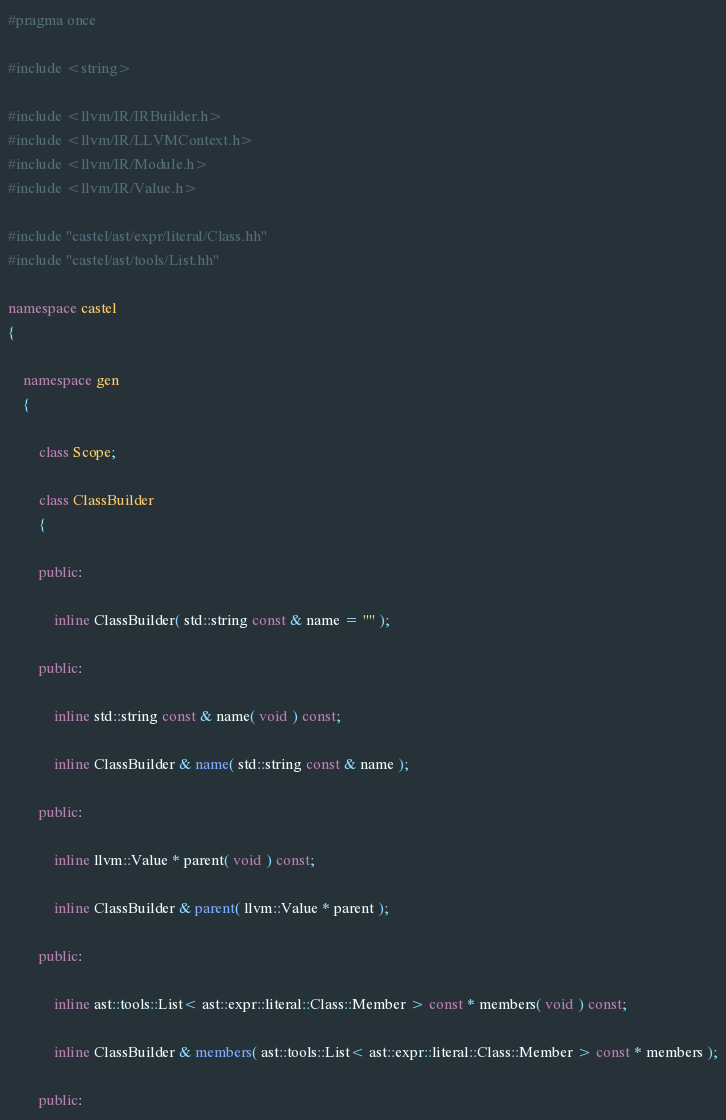<code> <loc_0><loc_0><loc_500><loc_500><_C++_>#pragma once

#include <string>

#include <llvm/IR/IRBuilder.h>
#include <llvm/IR/LLVMContext.h>
#include <llvm/IR/Module.h>
#include <llvm/IR/Value.h>

#include "castel/ast/expr/literal/Class.hh"
#include "castel/ast/tools/List.hh"

namespace castel
{

    namespace gen
    {

        class Scope;

        class ClassBuilder
        {

        public:

            inline ClassBuilder( std::string const & name = "" );

        public:

            inline std::string const & name( void ) const;

            inline ClassBuilder & name( std::string const & name );

        public:

            inline llvm::Value * parent( void ) const;

            inline ClassBuilder & parent( llvm::Value * parent );

        public:

            inline ast::tools::List< ast::expr::literal::Class::Member > const * members( void ) const;

            inline ClassBuilder & members( ast::tools::List< ast::expr::literal::Class::Member > const * members );

        public:
</code> 